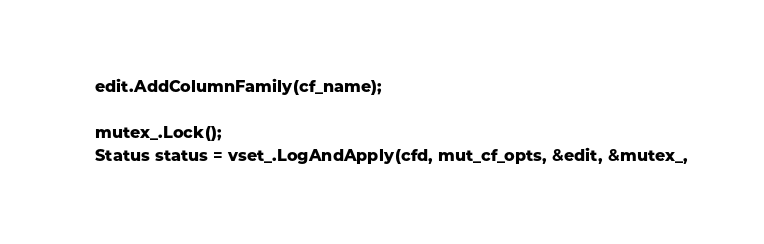<code> <loc_0><loc_0><loc_500><loc_500><_C++_>    edit.AddColumnFamily(cf_name);

    mutex_.Lock();
    Status status = vset_.LogAndApply(cfd, mut_cf_opts, &edit, &mutex_,</code> 